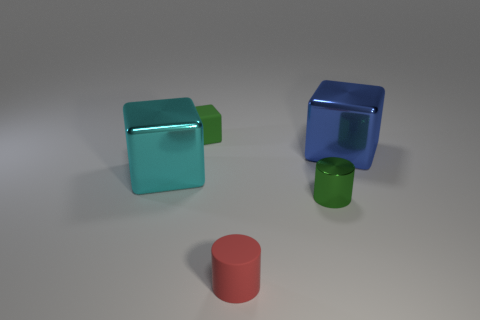There is another object that is the same color as the tiny metallic thing; what size is it?
Provide a short and direct response. Small. There is a thing that is the same color as the tiny metallic cylinder; what material is it?
Keep it short and to the point. Rubber. What color is the metal cube in front of the large metal cube right of the tiny green shiny cylinder?
Your answer should be compact. Cyan. What number of objects are either big objects to the right of the tiny green rubber block or small green cubes that are on the left side of the small red cylinder?
Ensure brevity in your answer.  2. Do the cyan metallic block and the rubber block have the same size?
Your answer should be compact. No. Is there anything else that is the same size as the blue thing?
Your answer should be compact. Yes. Is the shape of the blue metal object that is behind the metal cylinder the same as the green thing that is on the right side of the red object?
Keep it short and to the point. No. The blue shiny cube has what size?
Give a very brief answer. Large. There is a block right of the matte thing that is behind the shiny block on the left side of the red matte thing; what is it made of?
Make the answer very short. Metal. How many other things are there of the same color as the small metal thing?
Provide a succinct answer. 1. 